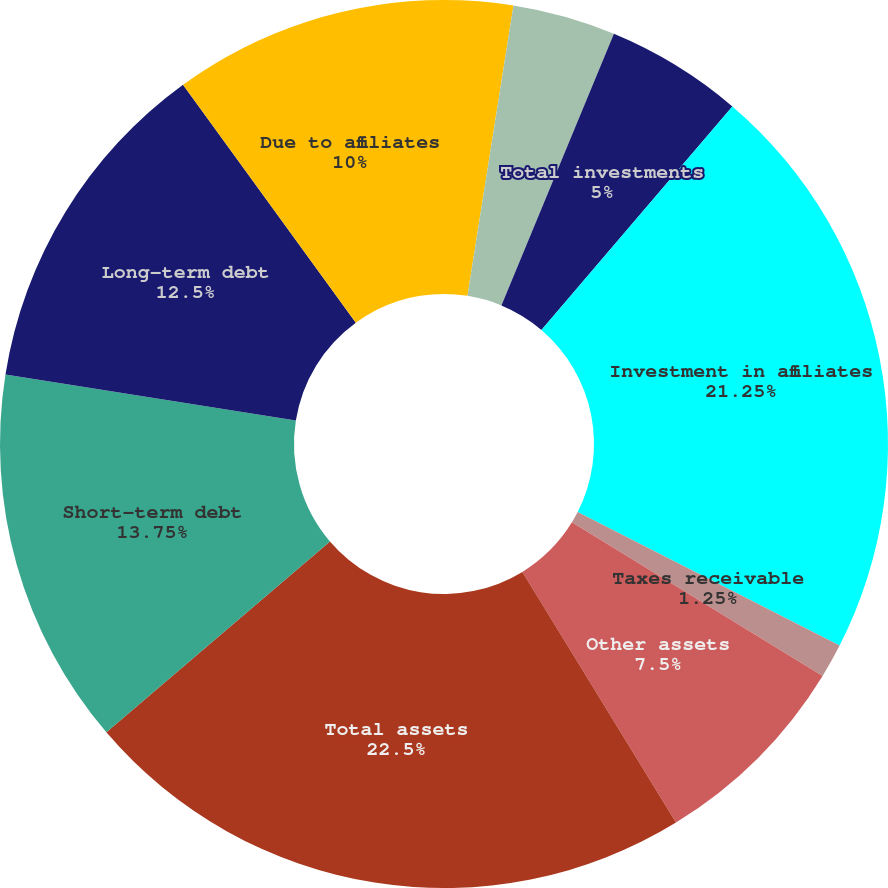Convert chart. <chart><loc_0><loc_0><loc_500><loc_500><pie_chart><fcel>Long-term investments<fcel>Short-term investments<fcel>Total investments<fcel>Investment in affiliates<fcel>Taxes receivable<fcel>Other assets<fcel>Total assets<fcel>Short-term debt<fcel>Long-term debt<fcel>Due to affiliates<nl><fcel>2.5%<fcel>3.75%<fcel>5.0%<fcel>21.25%<fcel>1.25%<fcel>7.5%<fcel>22.5%<fcel>13.75%<fcel>12.5%<fcel>10.0%<nl></chart> 